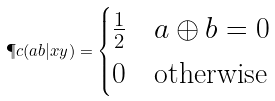Convert formula to latex. <formula><loc_0><loc_0><loc_500><loc_500>\P c ( a b | x y ) = \begin{cases} \frac { 1 } { 2 } & \text {$ a \oplus b = 0$} \\ 0 & \text {otherwise} \end{cases}</formula> 